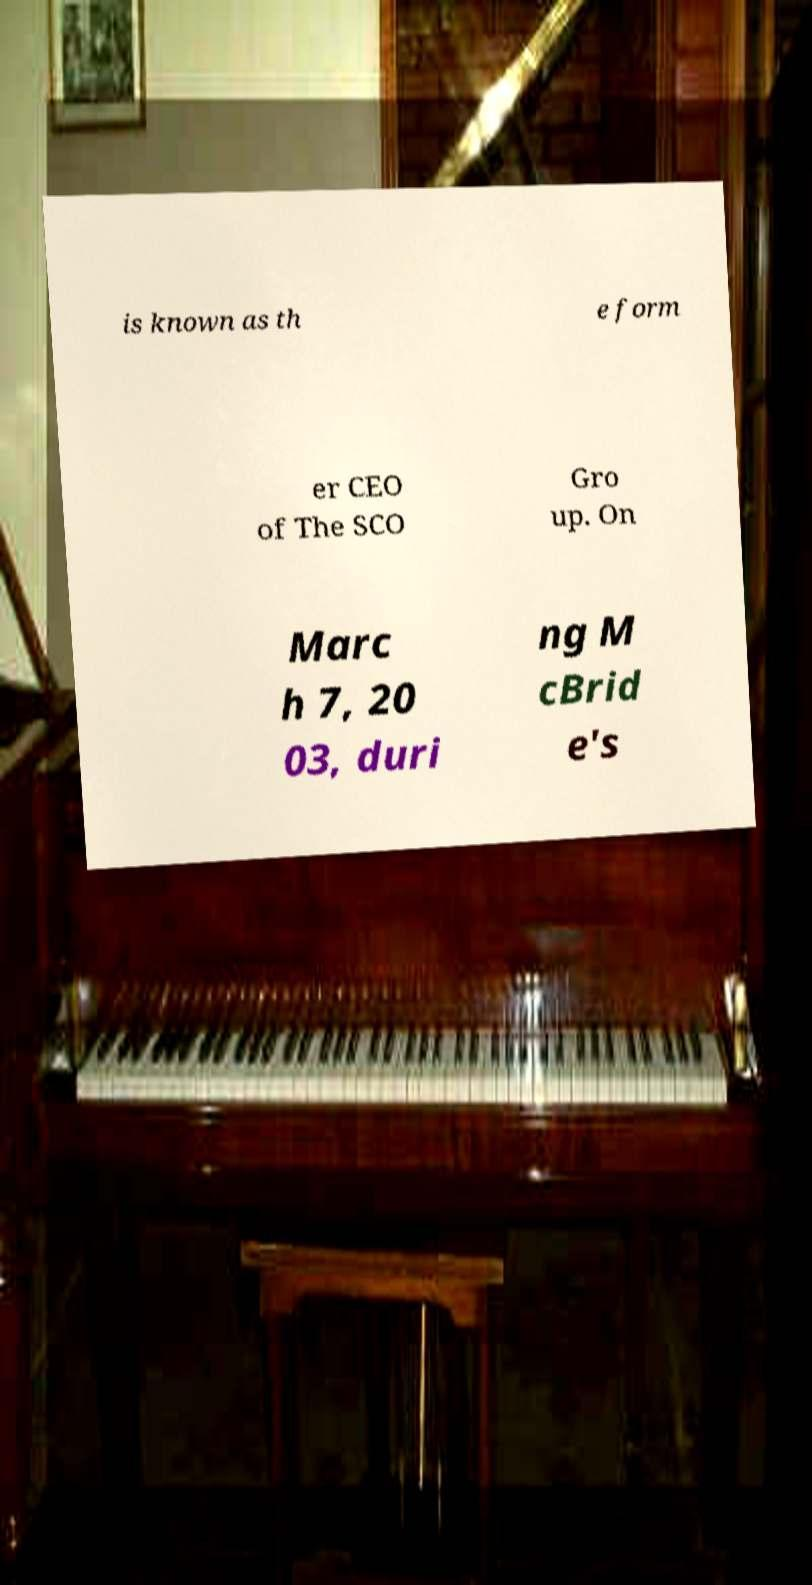Can you accurately transcribe the text from the provided image for me? is known as th e form er CEO of The SCO Gro up. On Marc h 7, 20 03, duri ng M cBrid e's 